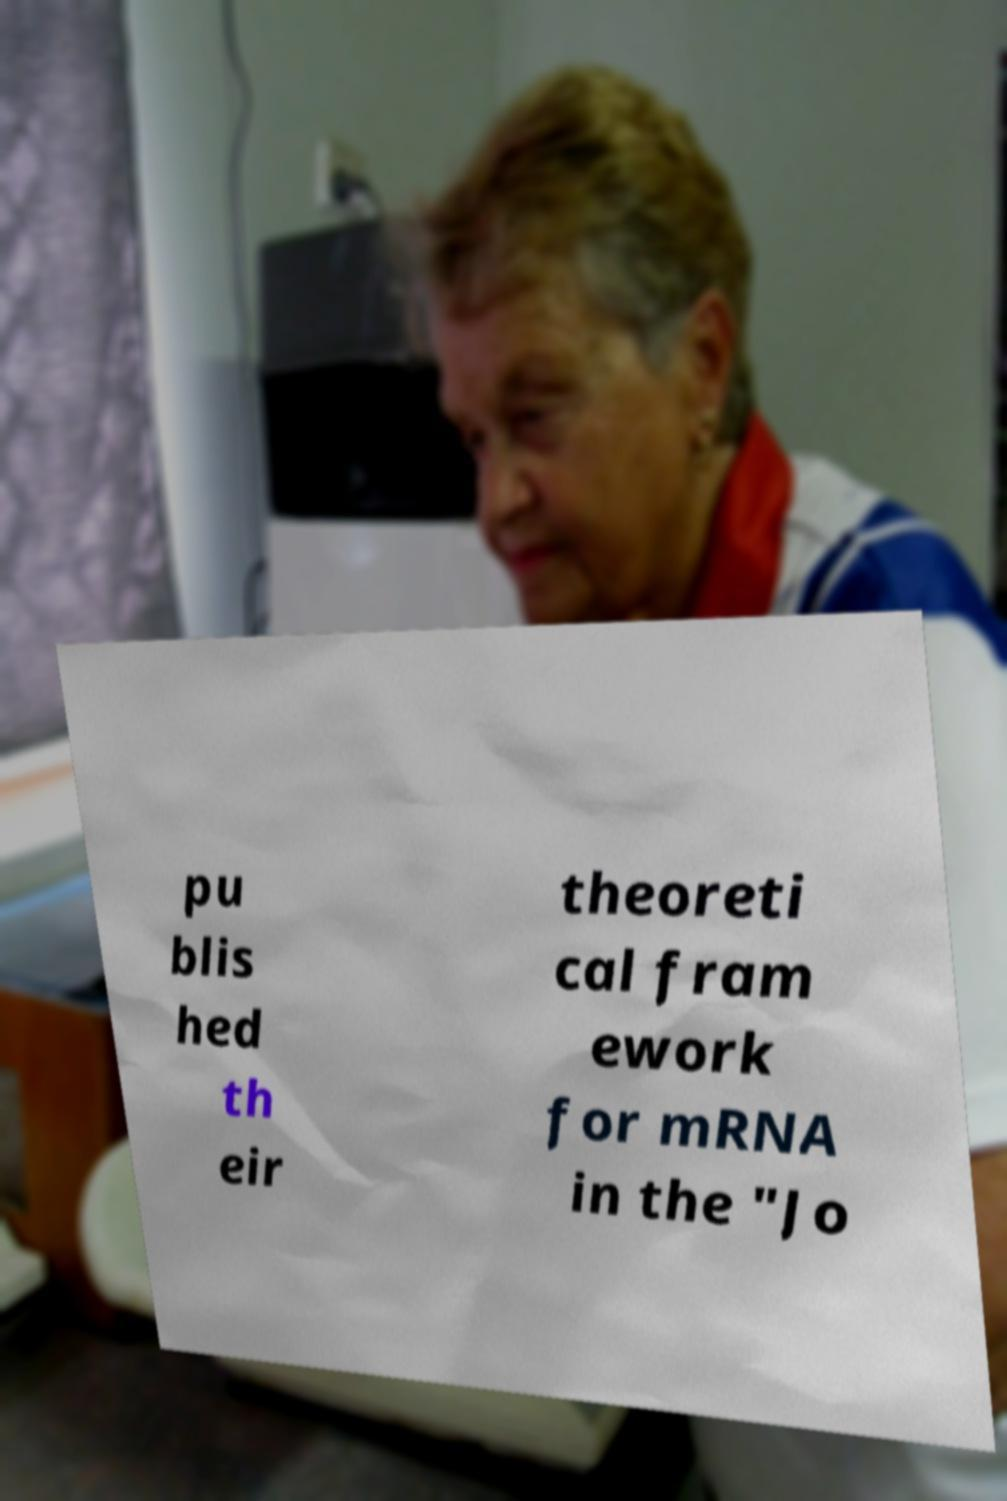Please identify and transcribe the text found in this image. pu blis hed th eir theoreti cal fram ework for mRNA in the "Jo 